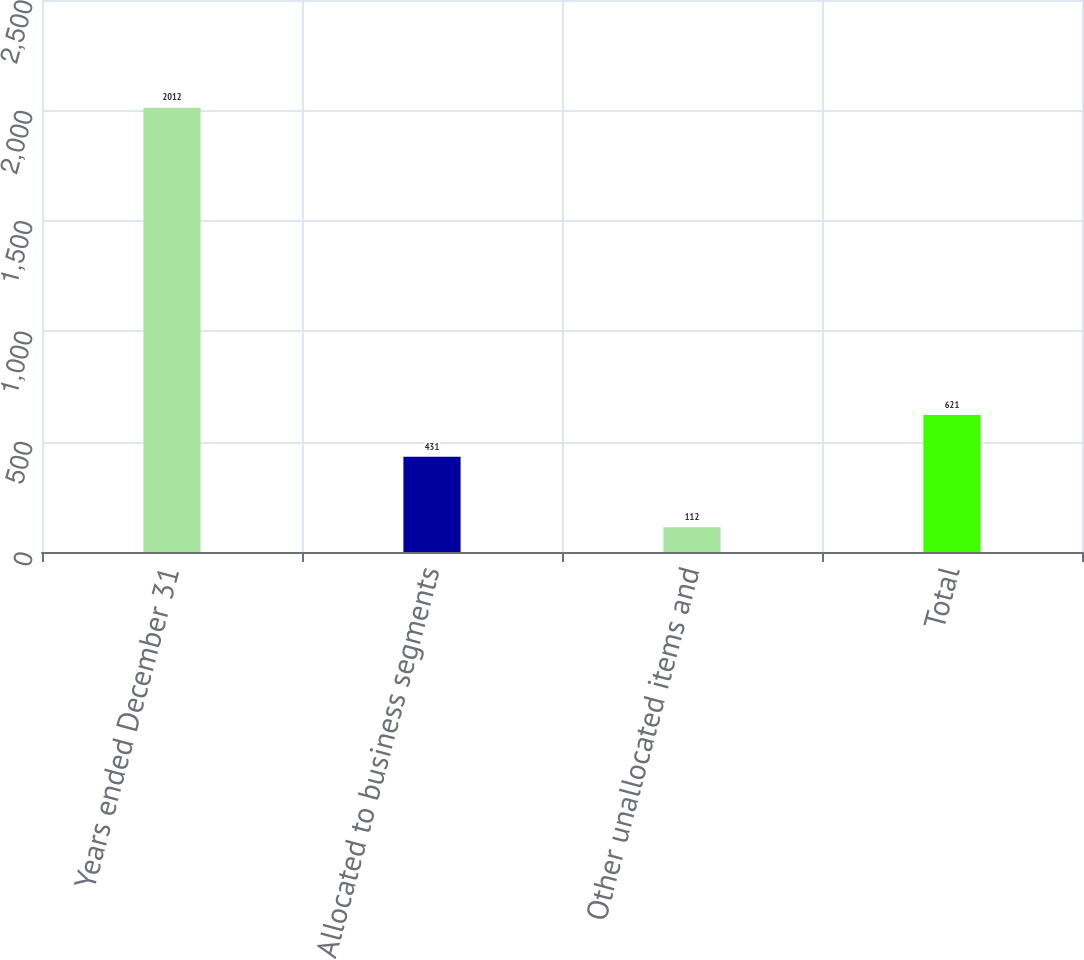<chart> <loc_0><loc_0><loc_500><loc_500><bar_chart><fcel>Years ended December 31<fcel>Allocated to business segments<fcel>Other unallocated items and<fcel>Total<nl><fcel>2012<fcel>431<fcel>112<fcel>621<nl></chart> 